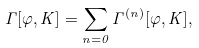<formula> <loc_0><loc_0><loc_500><loc_500>\Gamma [ \varphi , K ] = \sum _ { n = 0 } \Gamma ^ { ( n ) } [ \varphi , K ] ,</formula> 